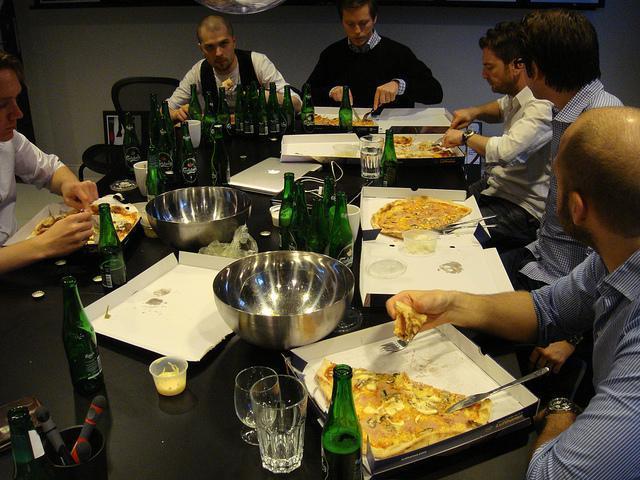How many people are seated?
Give a very brief answer. 6. How many bowls are in the photo?
Give a very brief answer. 2. How many pizzas can you see?
Give a very brief answer. 2. How many people are there?
Give a very brief answer. 6. How many dining tables are there?
Give a very brief answer. 1. How many bottles are there?
Give a very brief answer. 3. 